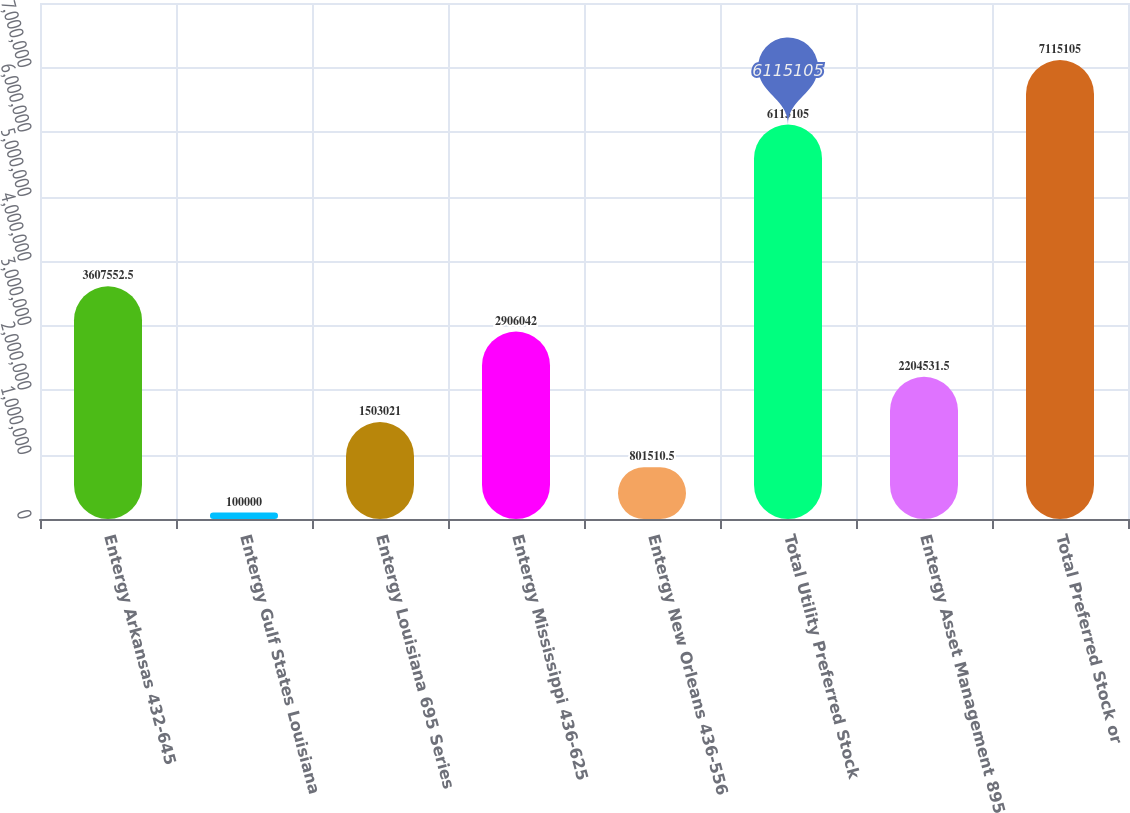Convert chart to OTSL. <chart><loc_0><loc_0><loc_500><loc_500><bar_chart><fcel>Entergy Arkansas 432-645<fcel>Entergy Gulf States Louisiana<fcel>Entergy Louisiana 695 Series<fcel>Entergy Mississippi 436-625<fcel>Entergy New Orleans 436-556<fcel>Total Utility Preferred Stock<fcel>Entergy Asset Management 895<fcel>Total Preferred Stock or<nl><fcel>3.60755e+06<fcel>100000<fcel>1.50302e+06<fcel>2.90604e+06<fcel>801510<fcel>6.1151e+06<fcel>2.20453e+06<fcel>7.1151e+06<nl></chart> 